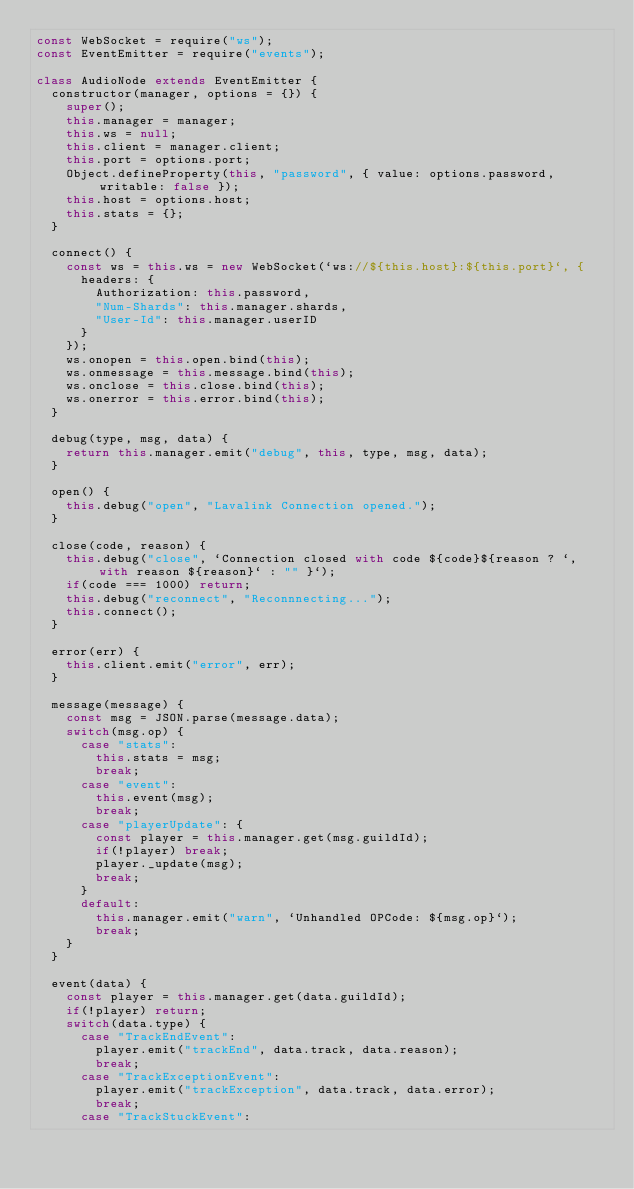Convert code to text. <code><loc_0><loc_0><loc_500><loc_500><_JavaScript_>const WebSocket = require("ws");
const EventEmitter = require("events");

class AudioNode extends EventEmitter {
  constructor(manager, options = {}) {
    super();
    this.manager = manager;
    this.ws = null;
    this.client = manager.client;
    this.port = options.port;
    Object.defineProperty(this, "password", { value: options.password, writable: false });
    this.host = options.host;
    this.stats = {};
  }
  
  connect() {
    const ws = this.ws = new WebSocket(`ws://${this.host}:${this.port}`, {
      headers: {
        Authorization: this.password,
        "Num-Shards": this.manager.shards,
        "User-Id": this.manager.userID
      }
    });
    ws.onopen = this.open.bind(this);
    ws.onmessage = this.message.bind(this);
    ws.onclose = this.close.bind(this);
    ws.onerror = this.error.bind(this);
  }

  debug(type, msg, data) {
    return this.manager.emit("debug", this, type, msg, data);
  }

  open() {
    this.debug("open", "Lavalink Connection opened.");
  }

  close(code, reason) {
    this.debug("close", `Connection closed with code ${code}${reason ? `, with reason ${reason}` : "" }`);
    if(code === 1000) return;
    this.debug("reconnect", "Reconnnecting...");
    this.connect();
  }

  error(err) {
    this.client.emit("error", err);
  }

  message(message) {
    const msg = JSON.parse(message.data);
    switch(msg.op) {
      case "stats":
        this.stats = msg;
        break;
      case "event":
        this.event(msg);
        break;
      case "playerUpdate": {
        const player = this.manager.get(msg.guildId);
        if(!player) break;
        player._update(msg);
        break;
      }
      default:
        this.manager.emit("warn", `Unhandled OPCode: ${msg.op}`);
        break;
    }
  }

  event(data) {
    const player = this.manager.get(data.guildId);
    if(!player) return;
    switch(data.type) {
      case "TrackEndEvent":
        player.emit("trackEnd", data.track, data.reason);
        break;
      case "TrackExceptionEvent":
        player.emit("trackException", data.track, data.error);
        break;
      case "TrackStuckEvent":</code> 